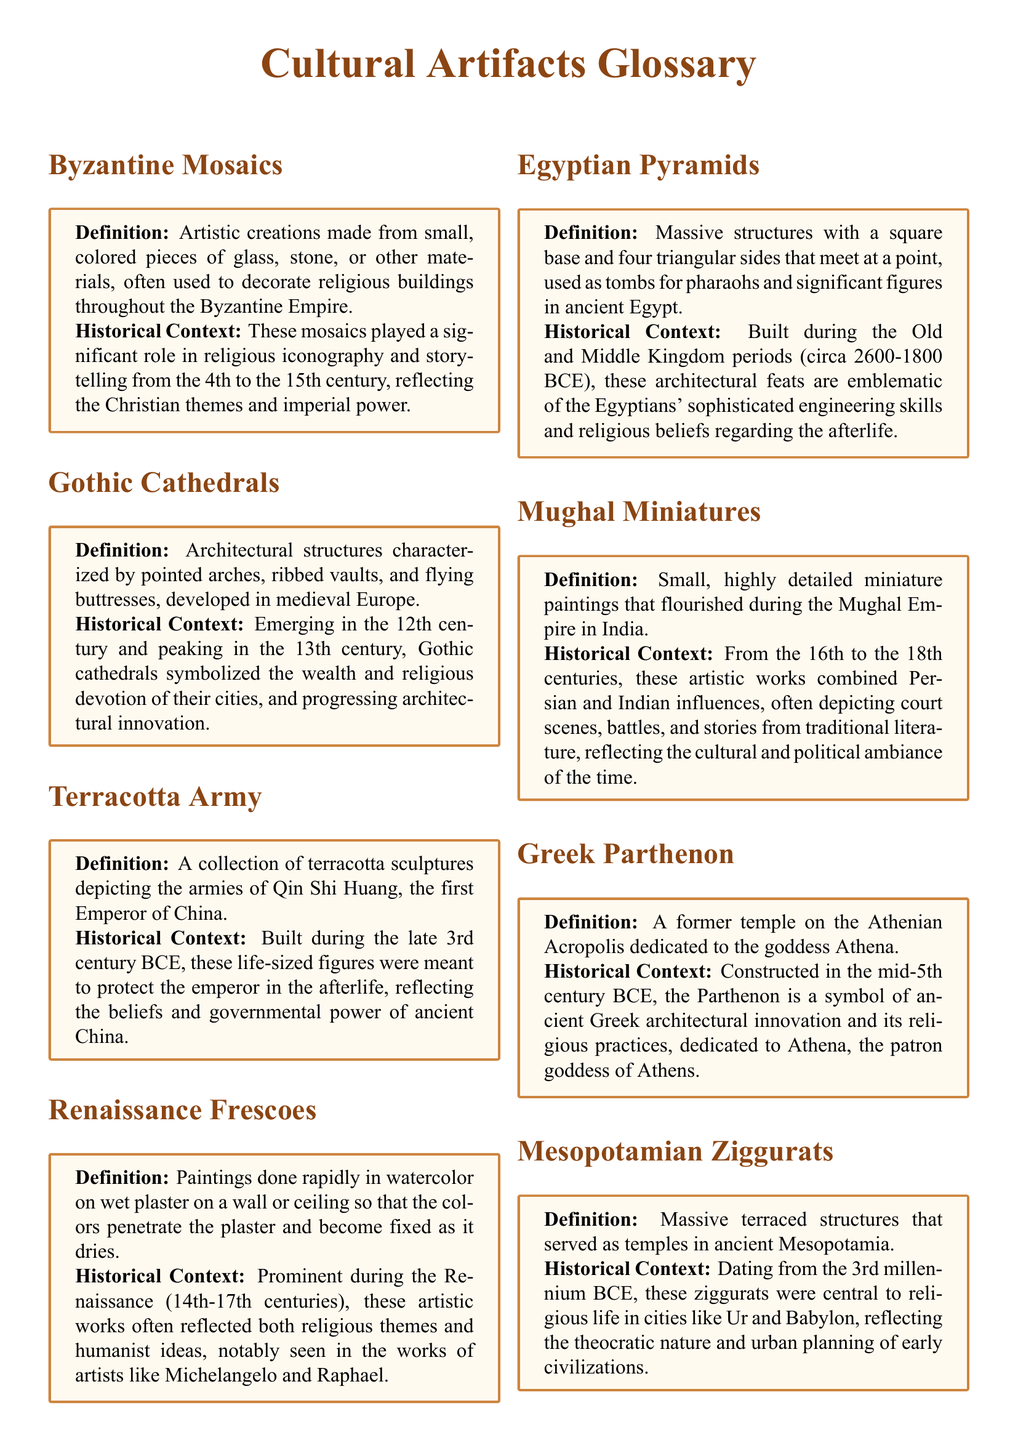What materials are used in Byzantine mosaics? The definition states that Byzantine mosaics are made from small, colored pieces of glass, stone, or other materials.
Answer: glass, stone When did Gothic cathedrals emerge? The historical context mentions that Gothic cathedrals emerged in the 12th century.
Answer: 12th century What was the purpose of the Terracotta Army? The historical context explains that the Terracotta Army was built to protect the emperor in the afterlife.
Answer: protect the emperor Who were notable artists of Renaissance frescoes? The historical context notes that significant artists include Michelangelo and Raphael.
Answer: Michelangelo, Raphael What period are the Egyptian pyramids associated with? The historical context specifies the construction of the Egyptian pyramids during the Old and Middle Kingdom periods.
Answer: Old and Middle Kingdom What artistic influences are seen in Mughal miniatures? The historical context states that Mughal miniatures reflect Persian and Indian influences.
Answer: Persian and Indian When was the Greek Parthenon constructed? The historical context indicates that the Parthenon was constructed in the mid-5th century BCE.
Answer: mid-5th century BCE What were Mesopotamian ziggurats used for? The definition states that ziggurats served as temples in ancient Mesopotamia.
Answer: temples 